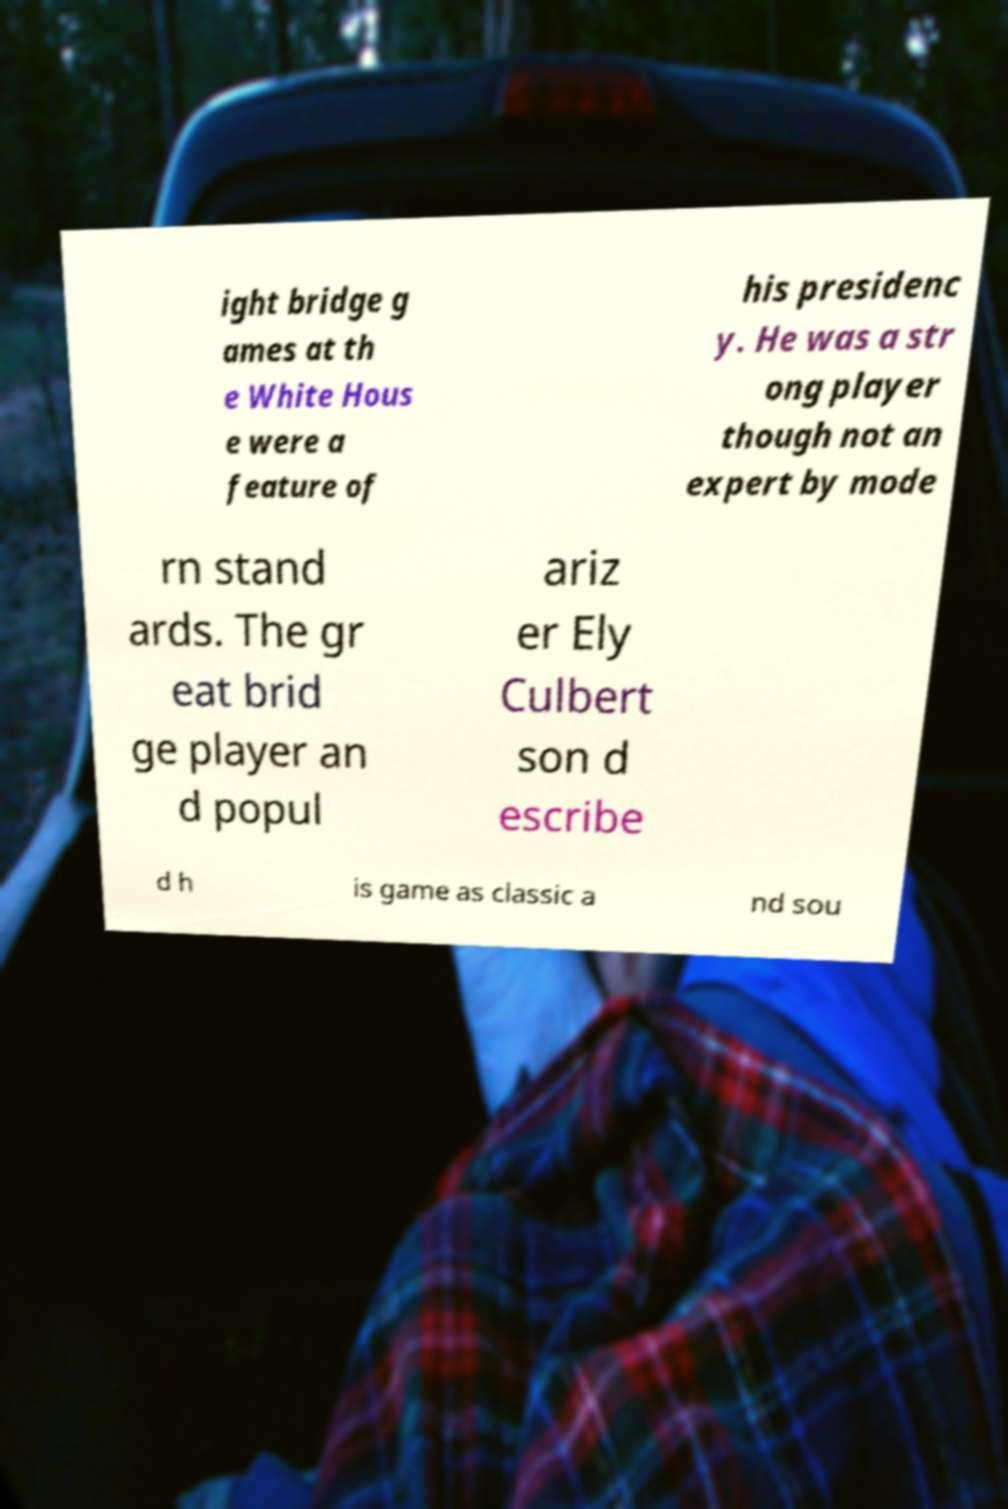Can you accurately transcribe the text from the provided image for me? ight bridge g ames at th e White Hous e were a feature of his presidenc y. He was a str ong player though not an expert by mode rn stand ards. The gr eat brid ge player an d popul ariz er Ely Culbert son d escribe d h is game as classic a nd sou 